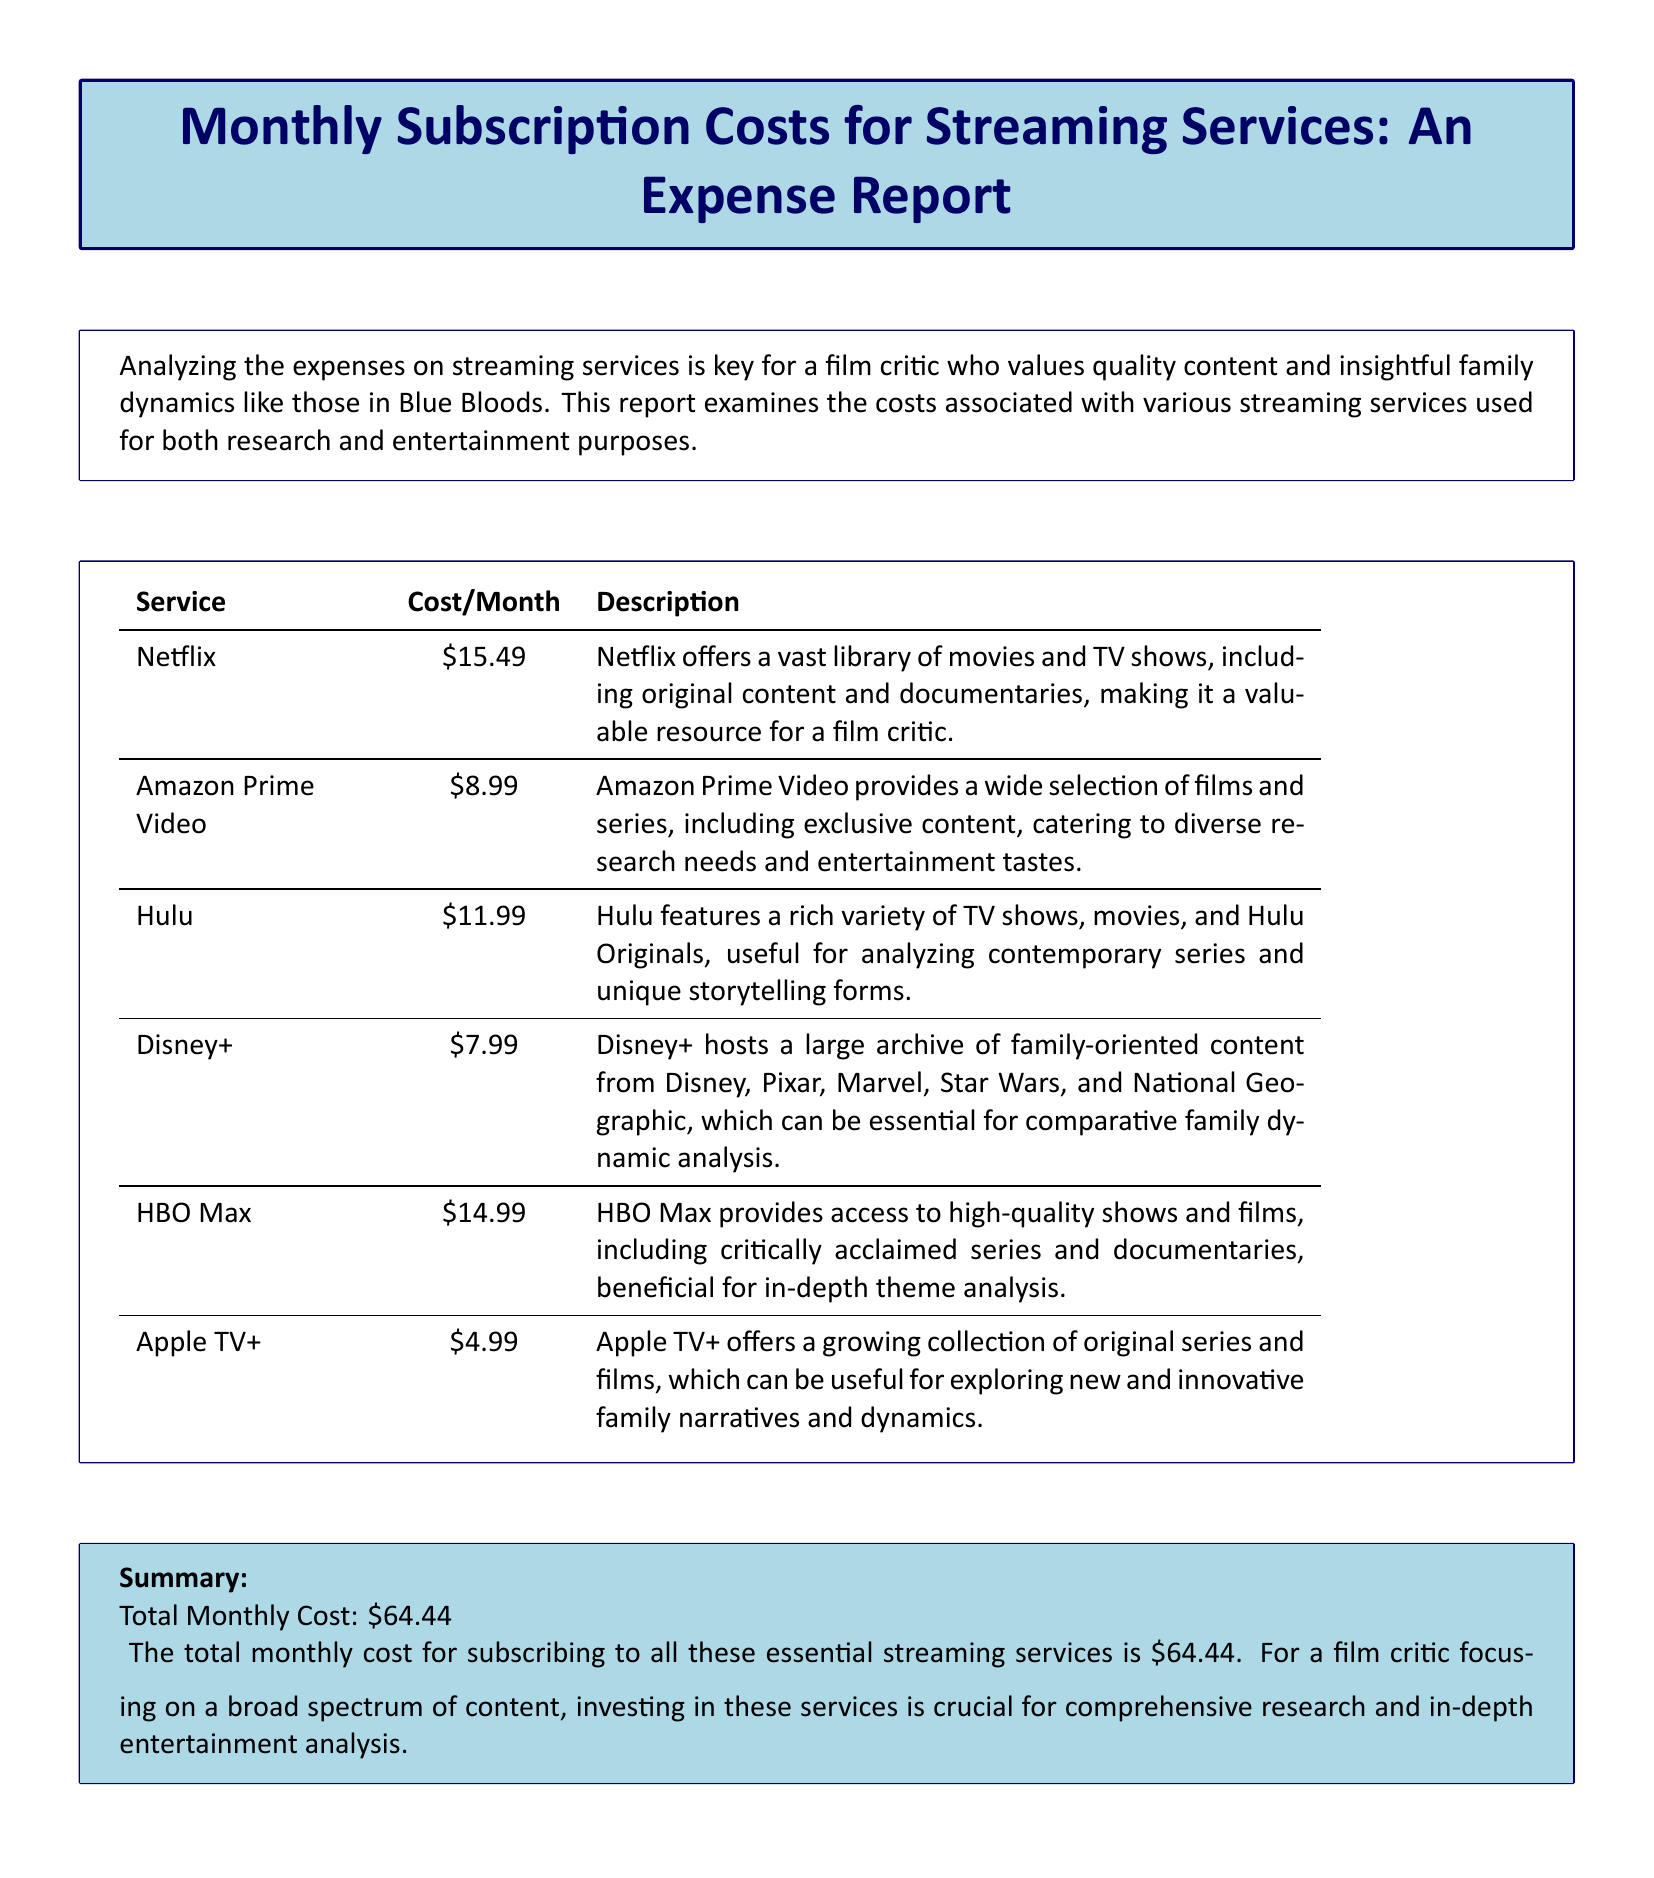What is the total monthly cost for streaming services? The total monthly cost is listed at the end of the report, which sums up all streaming service costs.
Answer: $64.44 How much does Netflix cost per month? The report contains a table that lists the cost of each streaming service, with Netflix being one of them.
Answer: $15.49 What streaming service costs the least? By analyzing the cost information provided in the table, we identify the service with the lowest cost.
Answer: Apple TV+ Which streaming service offers family-oriented content? The report includes descriptions for each service, highlighting what type of content they provide, including Disney's focus on family-oriented material.
Answer: Disney+ What is the monthly cost of HBO Max? The document presents a specific cost for HBO Max in the summary table of streaming services.
Answer: $14.99 Which service is noted for providing a variety of TV shows and Hulu Originals? The table lists each service along with their descriptions, including Hulu's offerings.
Answer: Hulu How many streaming services are detailed in the report? The total number of services can be counted directly from the table included in the document.
Answer: 6 What type of analysis is emphasized in this report? The introductory text explains the purpose of the report, which is related to expenses and the analysis of streaming services.
Answer: Film critique What is one reason for subscribing to these services? The report provides a rationale for the total monthly cost, linking it to the necessity for comprehensive research and entertainment analysis.
Answer: Research and analysis 